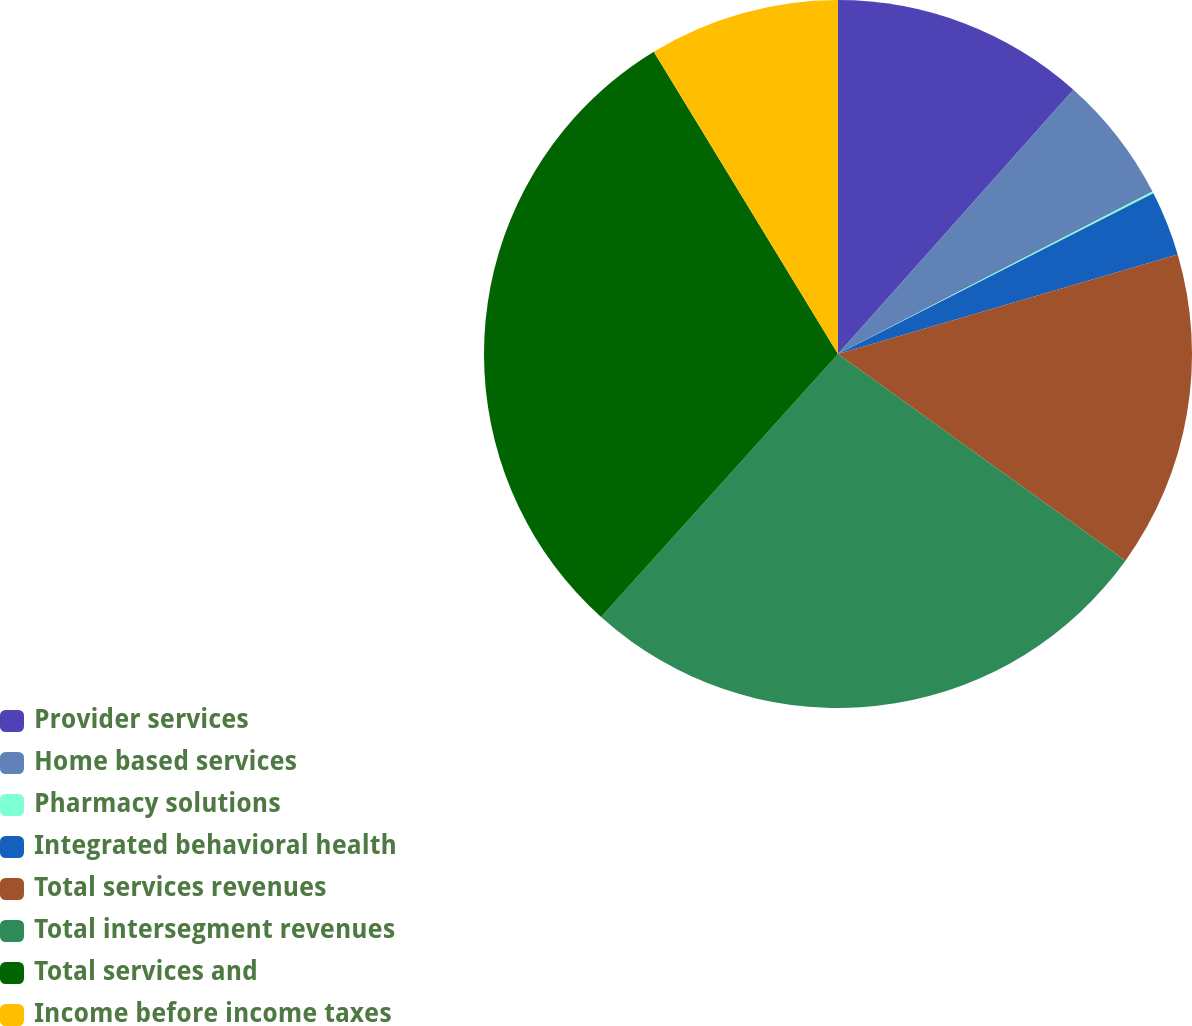<chart> <loc_0><loc_0><loc_500><loc_500><pie_chart><fcel>Provider services<fcel>Home based services<fcel>Pharmacy solutions<fcel>Integrated behavioral health<fcel>Total services revenues<fcel>Total intersegment revenues<fcel>Total services and<fcel>Income before income taxes<nl><fcel>11.58%<fcel>5.83%<fcel>0.09%<fcel>2.96%<fcel>14.46%<fcel>26.75%<fcel>29.62%<fcel>8.71%<nl></chart> 